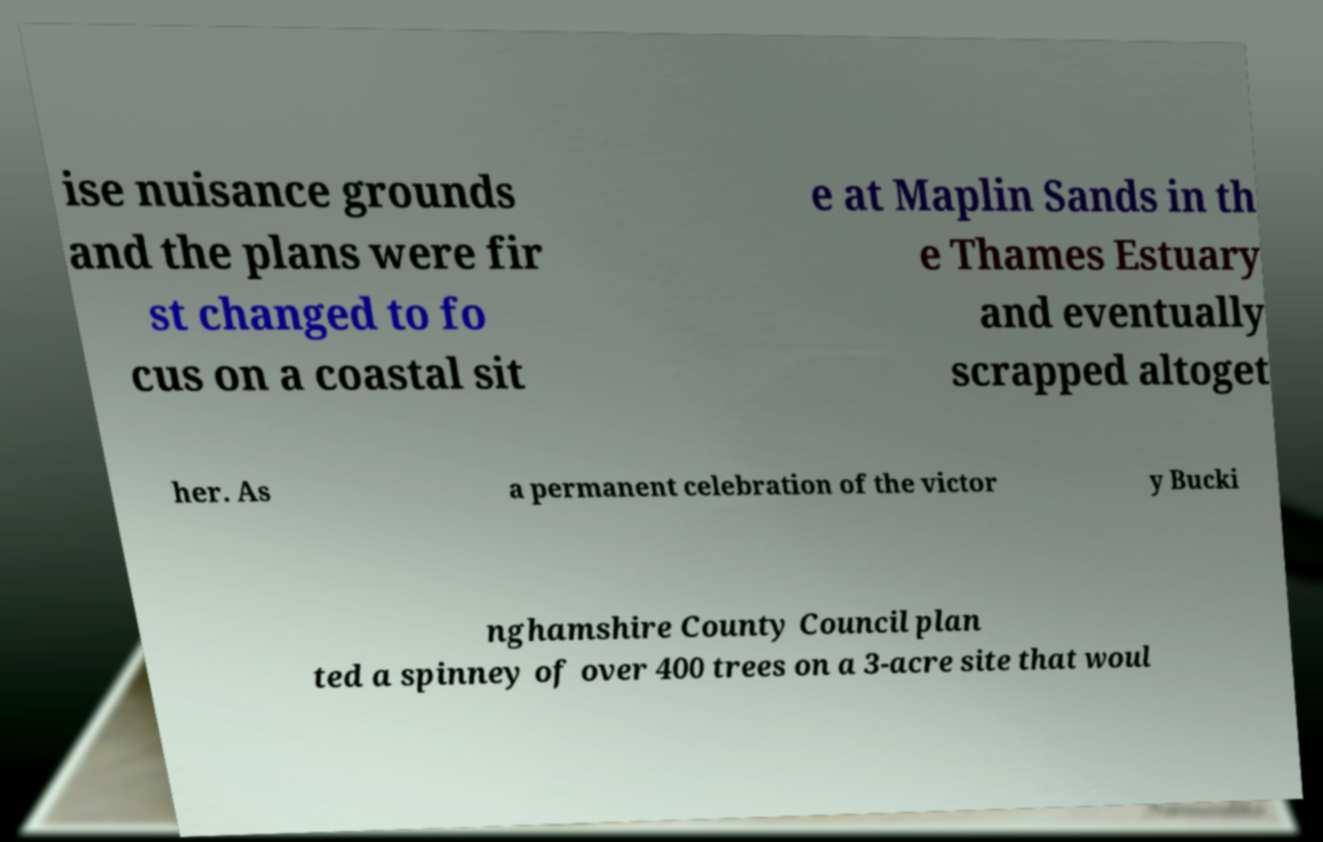I need the written content from this picture converted into text. Can you do that? ise nuisance grounds and the plans were fir st changed to fo cus on a coastal sit e at Maplin Sands in th e Thames Estuary and eventually scrapped altoget her. As a permanent celebration of the victor y Bucki nghamshire County Council plan ted a spinney of over 400 trees on a 3-acre site that woul 